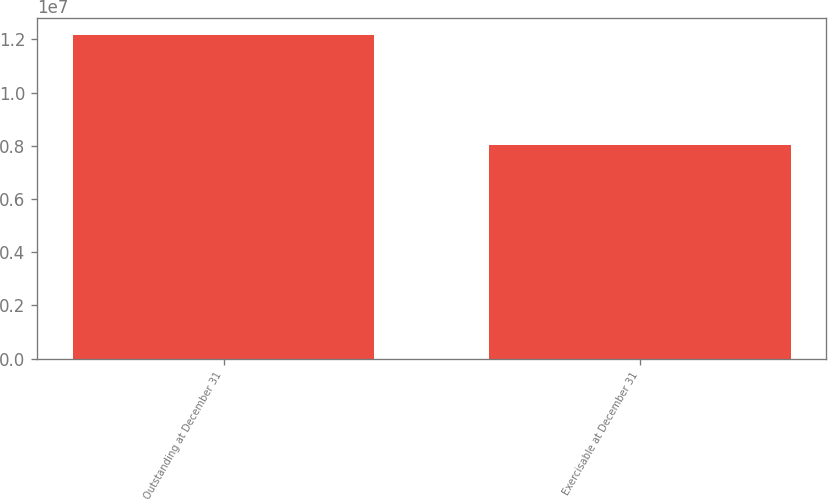Convert chart. <chart><loc_0><loc_0><loc_500><loc_500><bar_chart><fcel>Outstanding at December 31<fcel>Exercisable at December 31<nl><fcel>1.218e+07<fcel>8.04568e+06<nl></chart> 